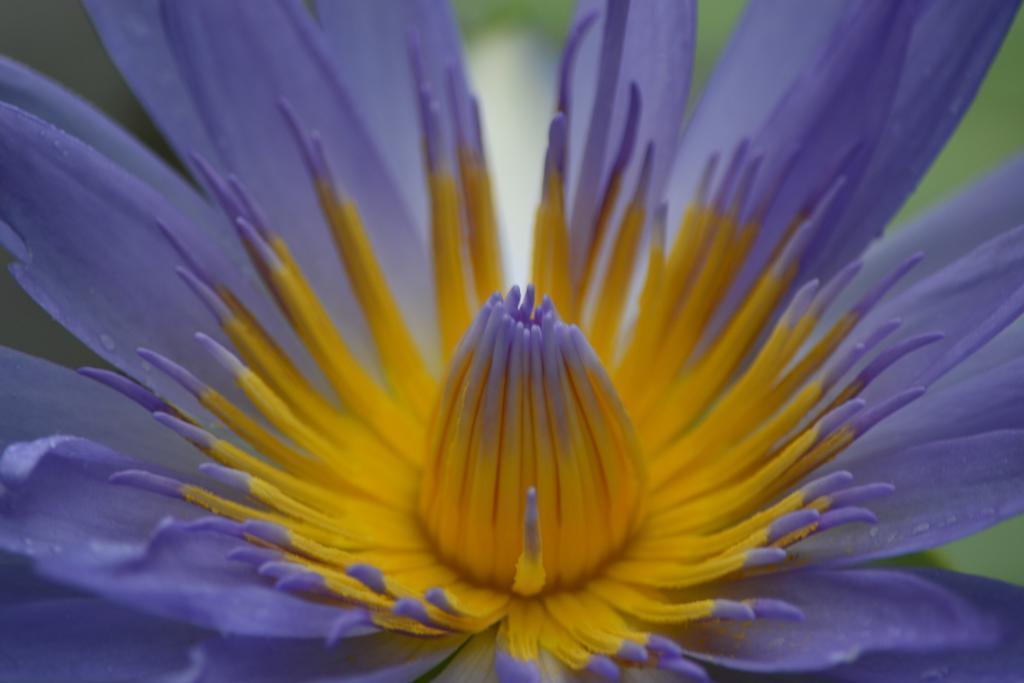Could you give a brief overview of what you see in this image? In this image I can see a flower. There is a blur background. 